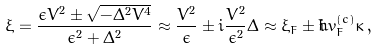Convert formula to latex. <formula><loc_0><loc_0><loc_500><loc_500>\xi = \frac { \epsilon V ^ { 2 } \pm \sqrt { - \Delta ^ { 2 } V ^ { 4 } } } { \epsilon ^ { 2 } + \Delta ^ { 2 } } \approx \frac { V ^ { 2 } } { \epsilon } \pm i \frac { V ^ { 2 } } { \epsilon ^ { 2 } } \Delta \approx \xi _ { F } \pm i \hbar { v } _ { F } ^ { ( c ) } \kappa \, ,</formula> 